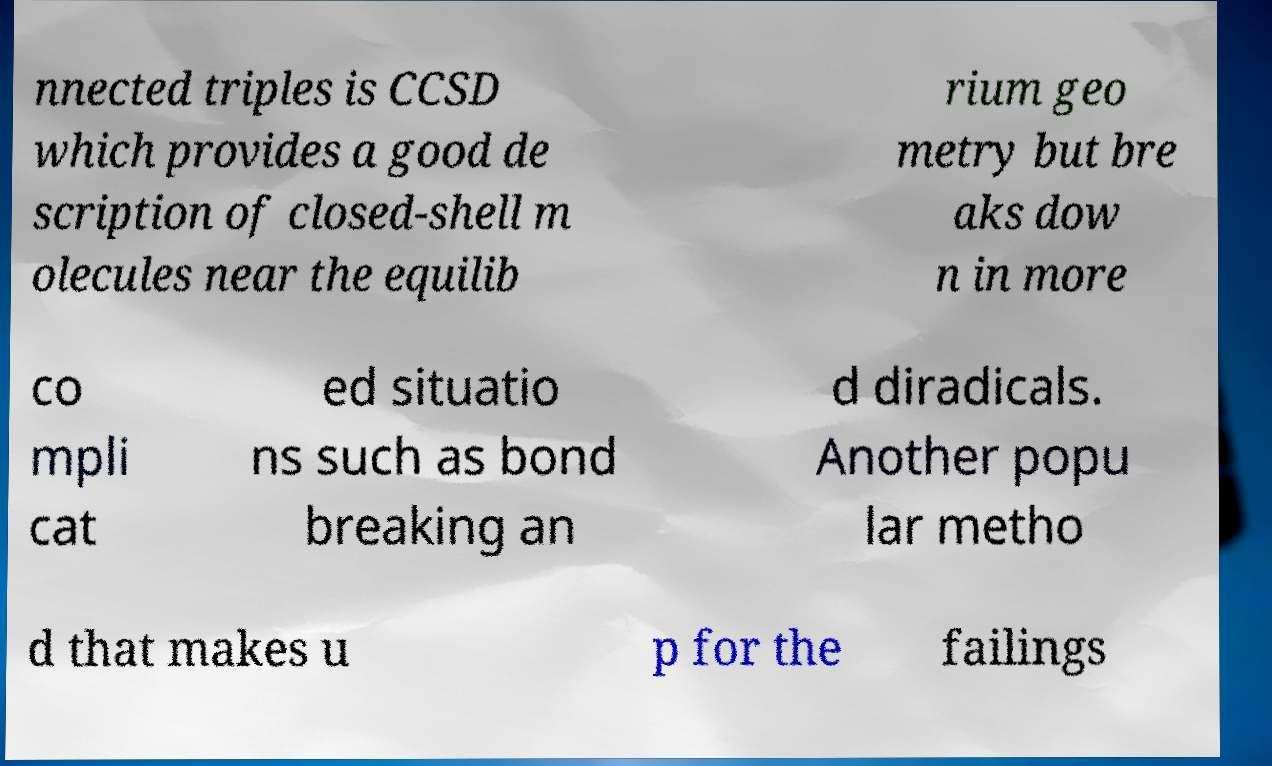What messages or text are displayed in this image? I need them in a readable, typed format. nnected triples is CCSD which provides a good de scription of closed-shell m olecules near the equilib rium geo metry but bre aks dow n in more co mpli cat ed situatio ns such as bond breaking an d diradicals. Another popu lar metho d that makes u p for the failings 